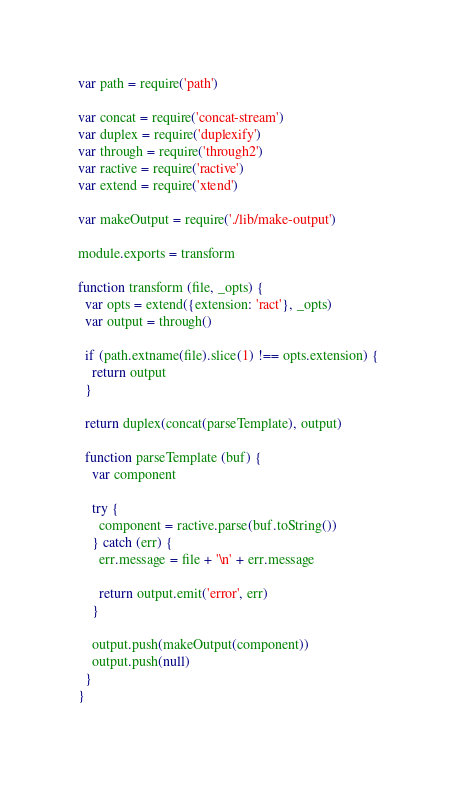<code> <loc_0><loc_0><loc_500><loc_500><_JavaScript_>var path = require('path')

var concat = require('concat-stream')
var duplex = require('duplexify')
var through = require('through2')
var ractive = require('ractive')
var extend = require('xtend')

var makeOutput = require('./lib/make-output')

module.exports = transform

function transform (file, _opts) {
  var opts = extend({extension: 'ract'}, _opts)
  var output = through()

  if (path.extname(file).slice(1) !== opts.extension) {
    return output
  }

  return duplex(concat(parseTemplate), output)

  function parseTemplate (buf) {
    var component

    try {
      component = ractive.parse(buf.toString())
    } catch (err) {
      err.message = file + '\n' + err.message

      return output.emit('error', err)
    }

    output.push(makeOutput(component))
    output.push(null)
  }
}
</code> 